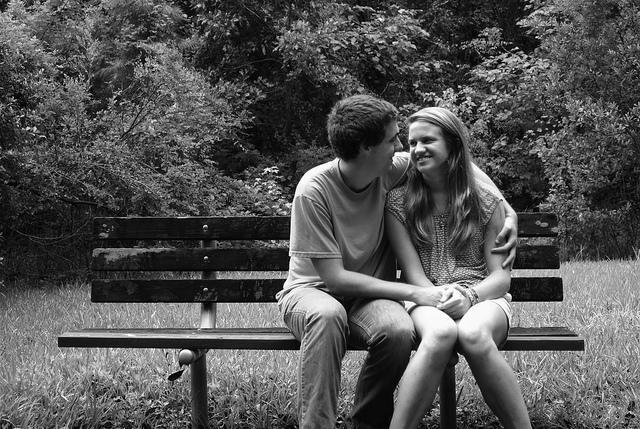How many people are in the photo?
Give a very brief answer. 2. How many already fried donuts are there in the image?
Give a very brief answer. 0. 